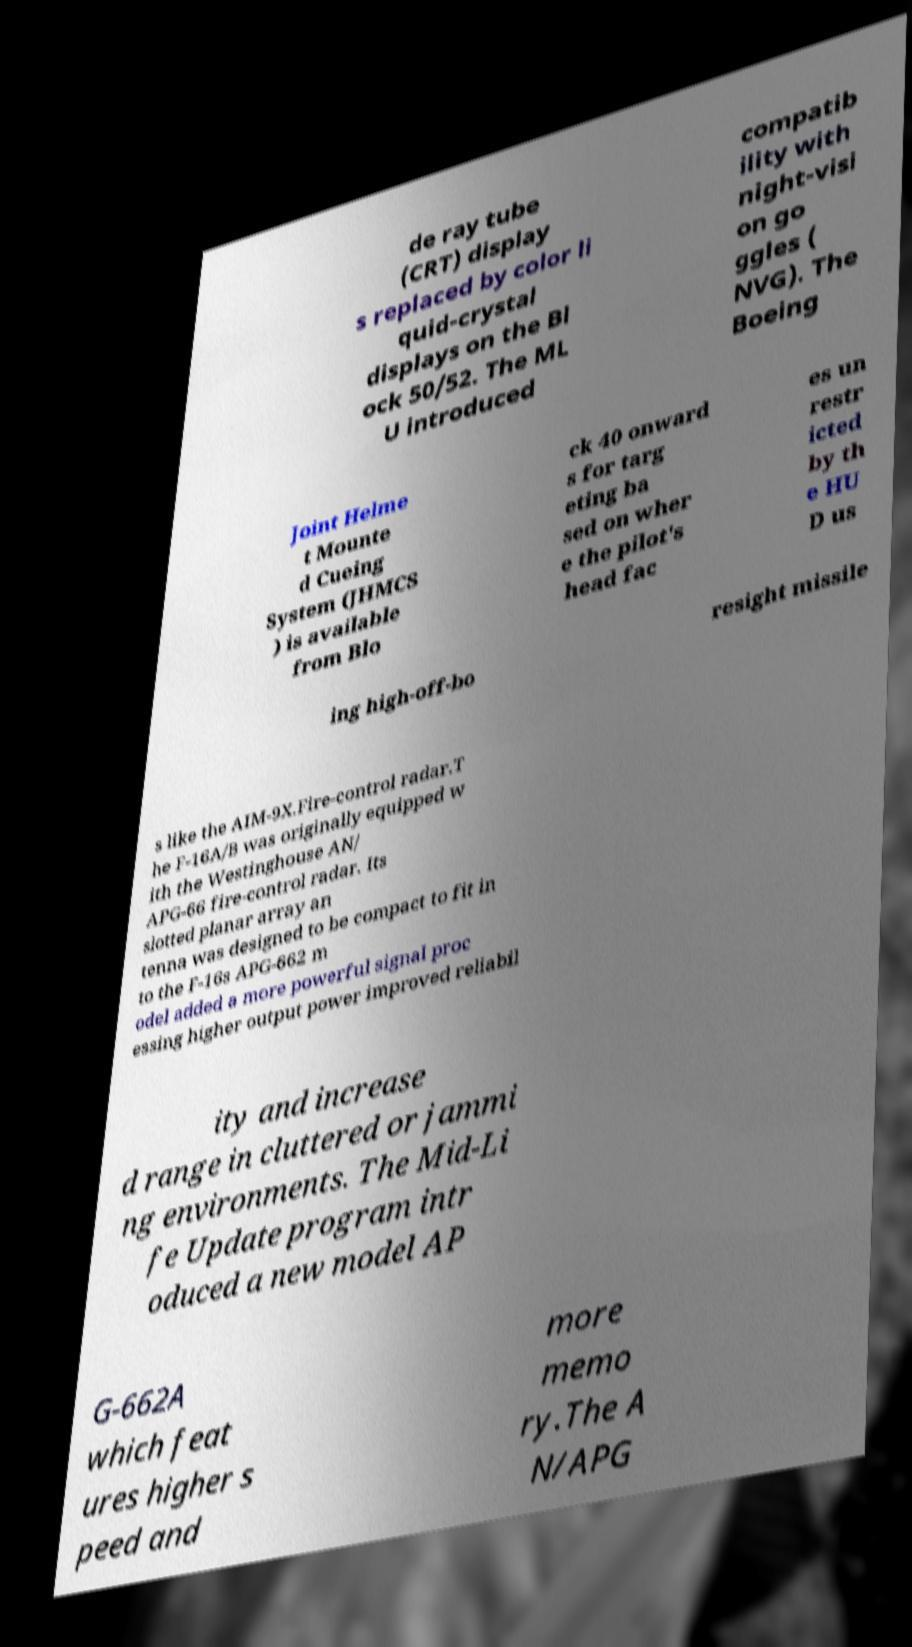For documentation purposes, I need the text within this image transcribed. Could you provide that? de ray tube (CRT) display s replaced by color li quid-crystal displays on the Bl ock 50/52. The ML U introduced compatib ility with night-visi on go ggles ( NVG). The Boeing Joint Helme t Mounte d Cueing System (JHMCS ) is available from Blo ck 40 onward s for targ eting ba sed on wher e the pilot's head fac es un restr icted by th e HU D us ing high-off-bo resight missile s like the AIM-9X.Fire-control radar.T he F-16A/B was originally equipped w ith the Westinghouse AN/ APG-66 fire-control radar. Its slotted planar array an tenna was designed to be compact to fit in to the F-16s APG-662 m odel added a more powerful signal proc essing higher output power improved reliabil ity and increase d range in cluttered or jammi ng environments. The Mid-Li fe Update program intr oduced a new model AP G-662A which feat ures higher s peed and more memo ry.The A N/APG 